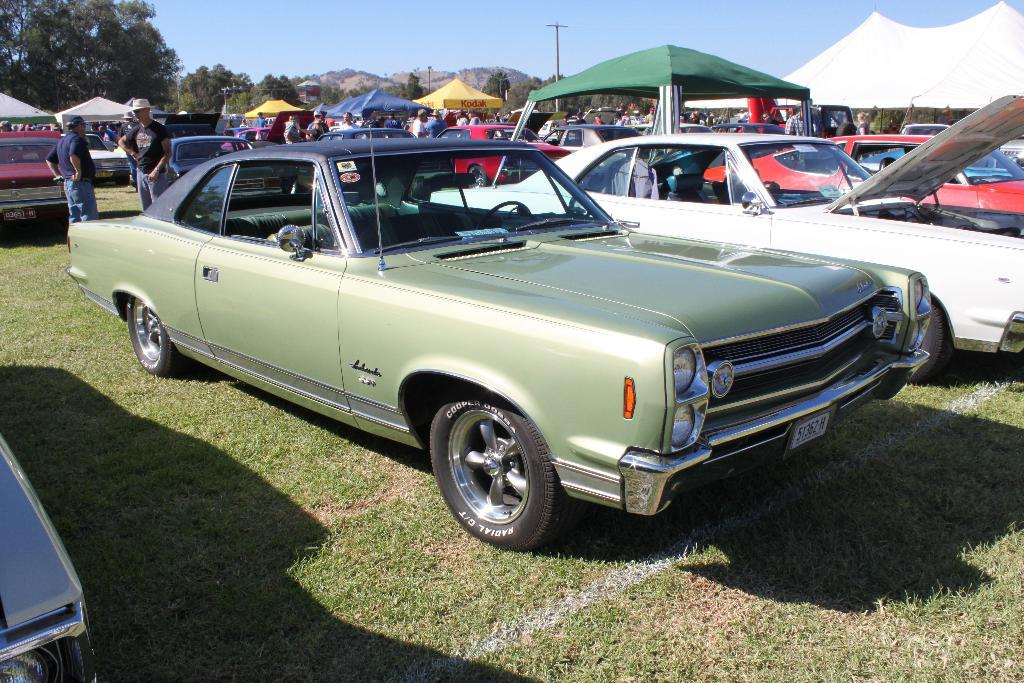Who or what can be seen in the image? There are people in the image. What is unusual about the location of the vehicles in the image? The vehicles are on the grass in the image. What type of temporary shelter is present in the image? There are tents in the image. What are the poles used for in the image? The poles are likely used for supporting tents or other structures in the image. What type of natural environment is visible in the image? There are trees in the image, indicating a natural environment. What is visible in the background of the image? The sky is visible in the background of the image. What type of father is present in the image? There is no mention of a father or any specific person in the image. 